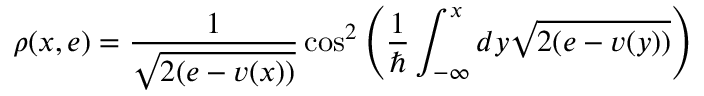Convert formula to latex. <formula><loc_0><loc_0><loc_500><loc_500>\rho ( x , e ) = \frac { 1 } { \sqrt { 2 ( e - v ( x ) ) } } \cos ^ { 2 } \left ( \frac { 1 } { } \int _ { - \infty } ^ { x } d y \sqrt { 2 ( e - v ( y ) ) } \right )</formula> 